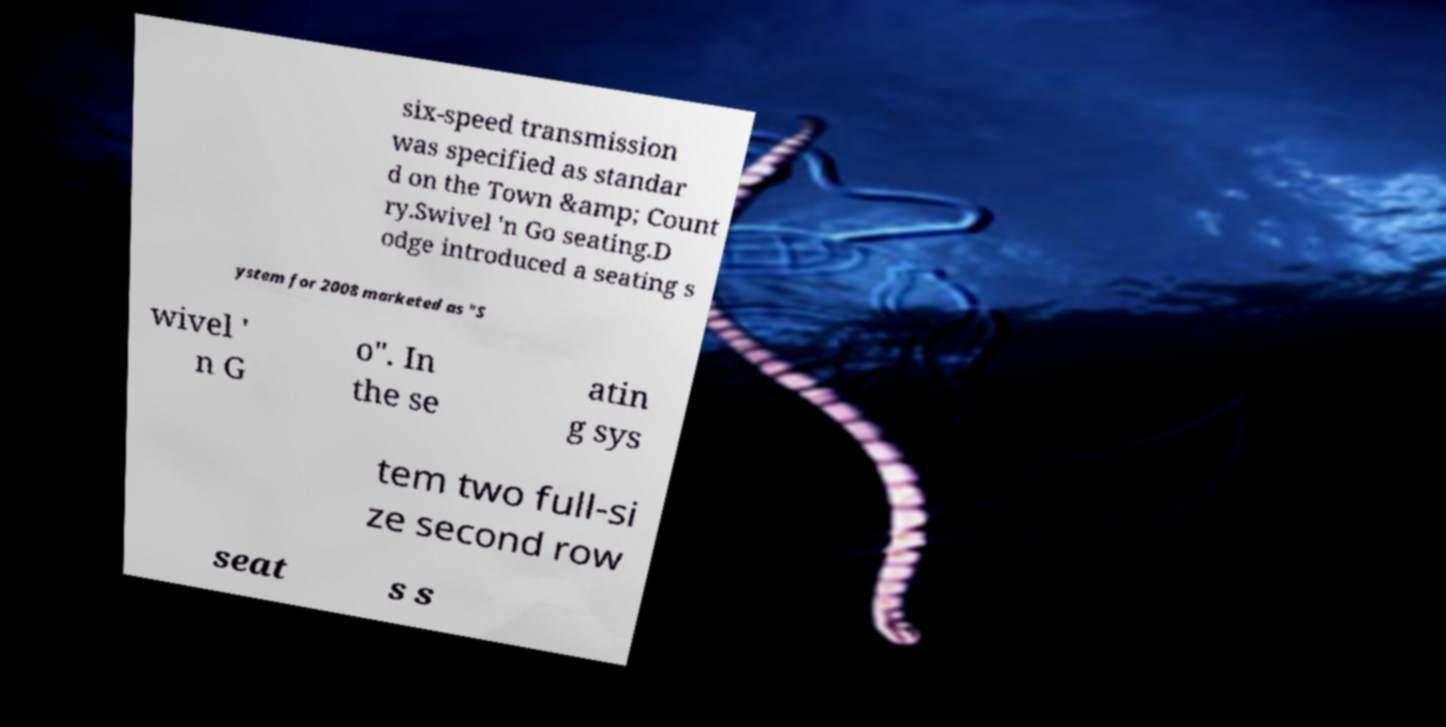I need the written content from this picture converted into text. Can you do that? six-speed transmission was specified as standar d on the Town &amp; Count ry.Swivel 'n Go seating.D odge introduced a seating s ystem for 2008 marketed as "S wivel ' n G o". In the se atin g sys tem two full-si ze second row seat s s 